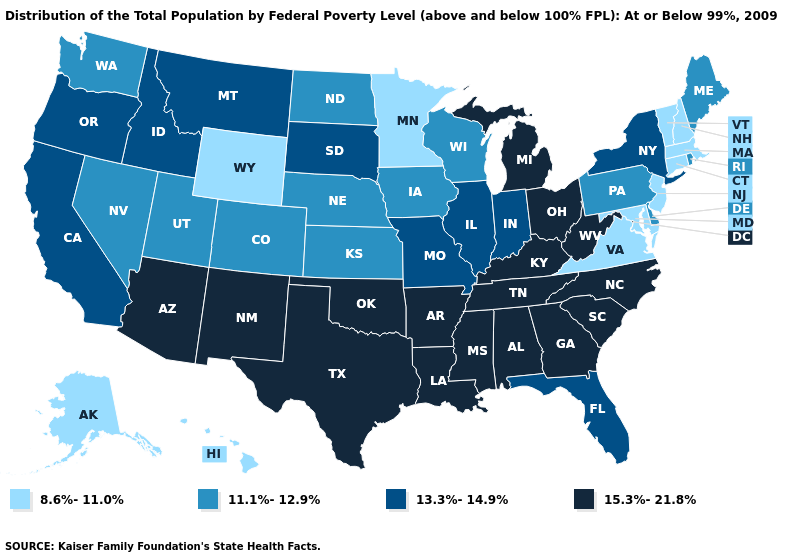Which states have the lowest value in the Northeast?
Answer briefly. Connecticut, Massachusetts, New Hampshire, New Jersey, Vermont. What is the value of Ohio?
Be succinct. 15.3%-21.8%. Does the map have missing data?
Answer briefly. No. What is the lowest value in the Northeast?
Concise answer only. 8.6%-11.0%. What is the highest value in the South ?
Give a very brief answer. 15.3%-21.8%. Name the states that have a value in the range 15.3%-21.8%?
Write a very short answer. Alabama, Arizona, Arkansas, Georgia, Kentucky, Louisiana, Michigan, Mississippi, New Mexico, North Carolina, Ohio, Oklahoma, South Carolina, Tennessee, Texas, West Virginia. Does Oregon have a higher value than Minnesota?
Be succinct. Yes. What is the value of Louisiana?
Keep it brief. 15.3%-21.8%. Name the states that have a value in the range 8.6%-11.0%?
Concise answer only. Alaska, Connecticut, Hawaii, Maryland, Massachusetts, Minnesota, New Hampshire, New Jersey, Vermont, Virginia, Wyoming. Name the states that have a value in the range 8.6%-11.0%?
Quick response, please. Alaska, Connecticut, Hawaii, Maryland, Massachusetts, Minnesota, New Hampshire, New Jersey, Vermont, Virginia, Wyoming. Name the states that have a value in the range 8.6%-11.0%?
Keep it brief. Alaska, Connecticut, Hawaii, Maryland, Massachusetts, Minnesota, New Hampshire, New Jersey, Vermont, Virginia, Wyoming. How many symbols are there in the legend?
Keep it brief. 4. What is the value of Oregon?
Give a very brief answer. 13.3%-14.9%. Which states have the lowest value in the USA?
Be succinct. Alaska, Connecticut, Hawaii, Maryland, Massachusetts, Minnesota, New Hampshire, New Jersey, Vermont, Virginia, Wyoming. What is the lowest value in the West?
Concise answer only. 8.6%-11.0%. 